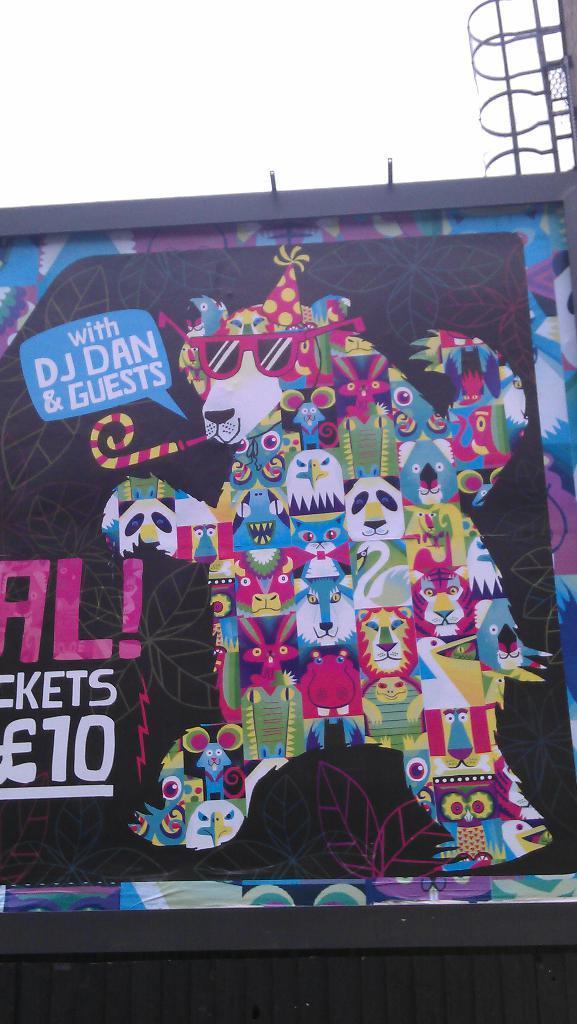Please provide a concise description of this image. In this image in the center there is painting on the wall with some text written on it. On the right side there is a stand. 